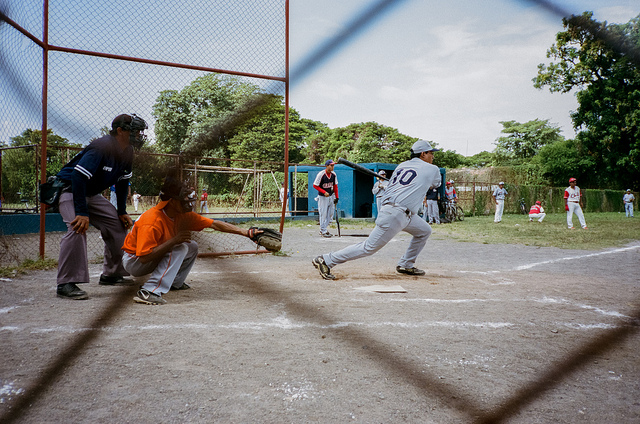<image>The layer sliding into home plate? I don't know if the player is sliding into home plate. The layer sliding into home plate? I am not sure which layer is sliding into home plate. It can be 'batter', 'yes' or 'sand'. 